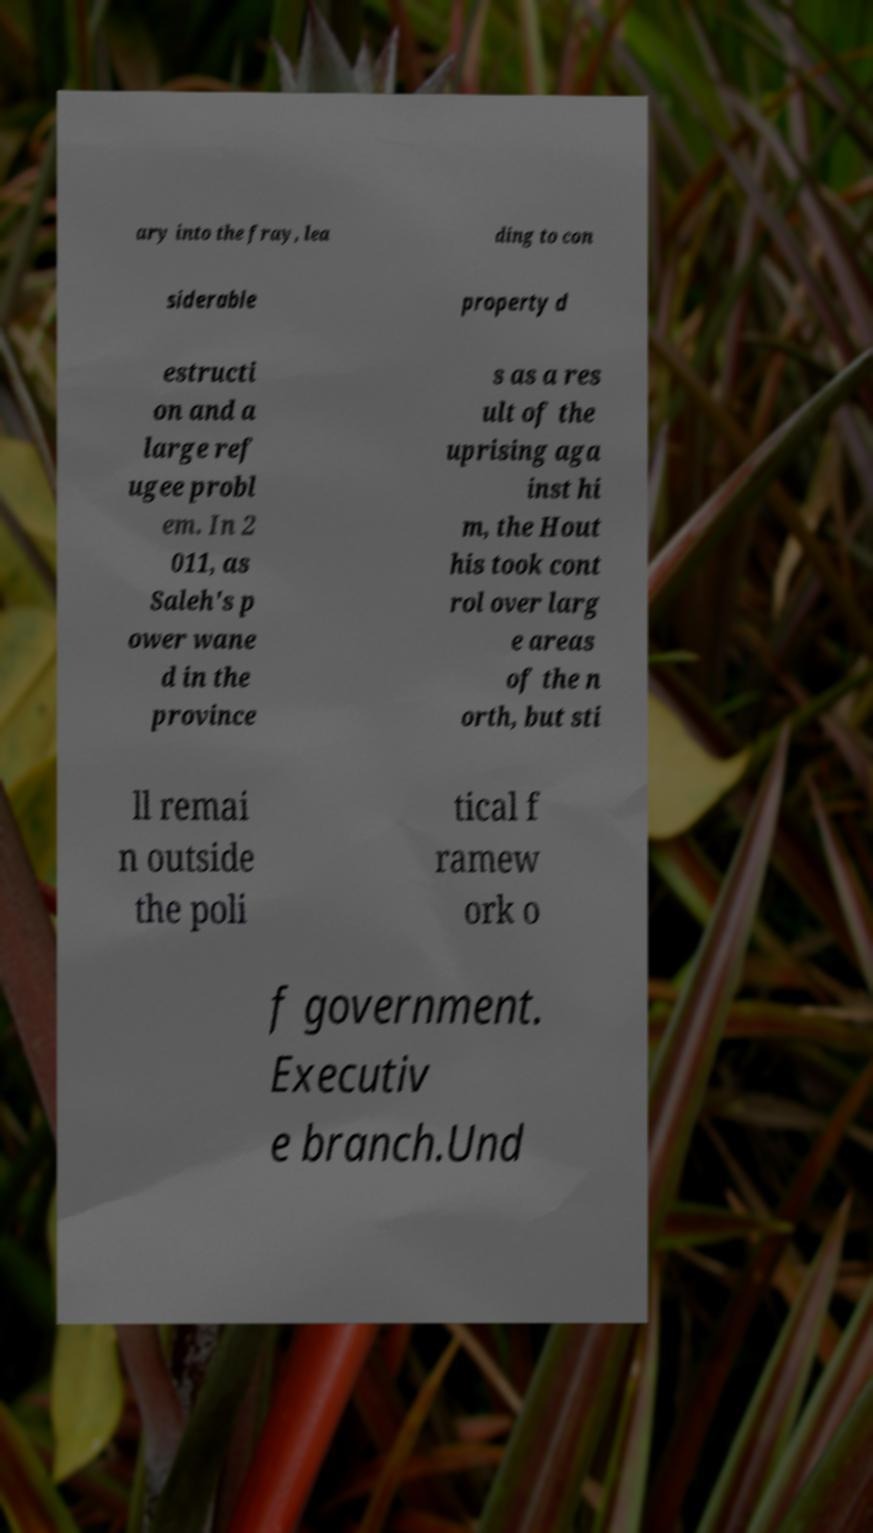Could you assist in decoding the text presented in this image and type it out clearly? ary into the fray, lea ding to con siderable property d estructi on and a large ref ugee probl em. In 2 011, as Saleh's p ower wane d in the province s as a res ult of the uprising aga inst hi m, the Hout his took cont rol over larg e areas of the n orth, but sti ll remai n outside the poli tical f ramew ork o f government. Executiv e branch.Und 